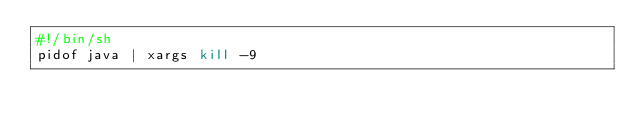Convert code to text. <code><loc_0><loc_0><loc_500><loc_500><_Bash_>#!/bin/sh
pidof java | xargs kill -9

</code> 